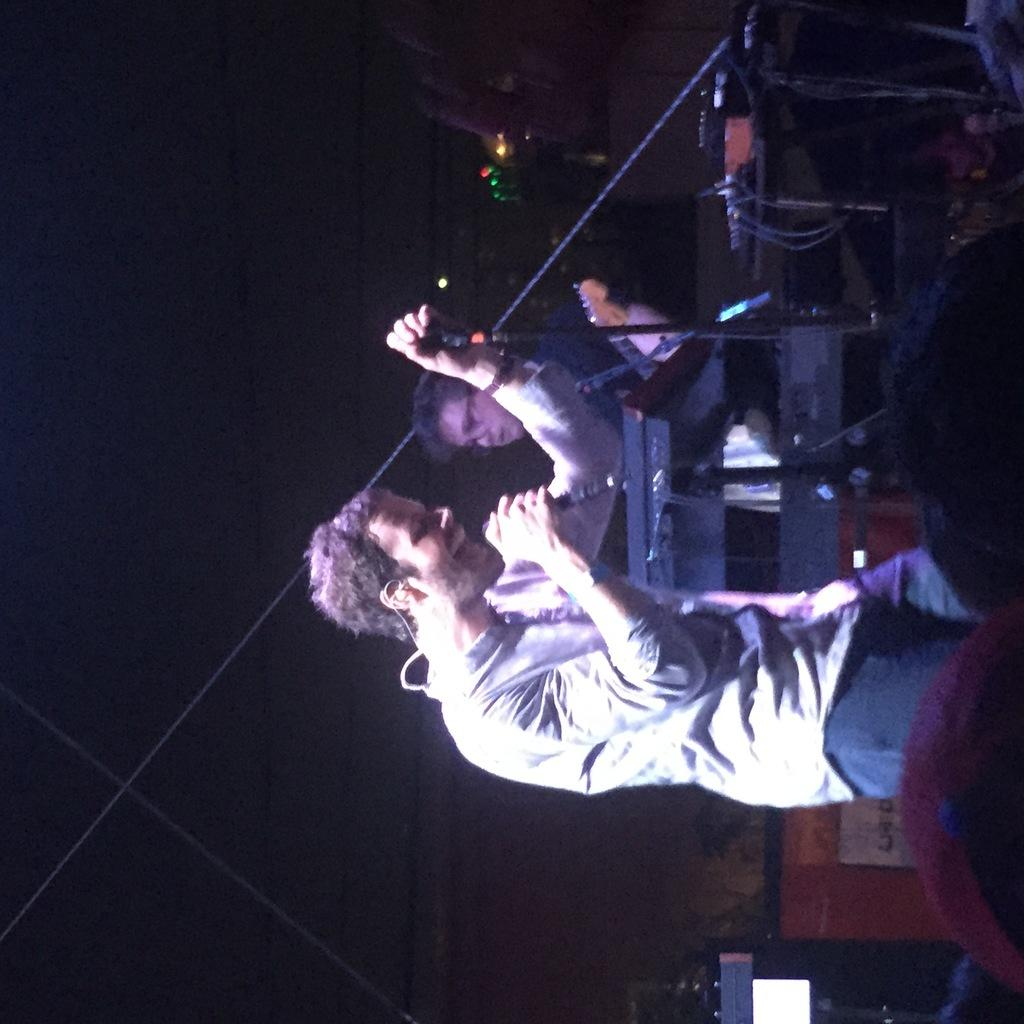What is happening on the stage in the image? There are people standing on the stage. What are the people on the stage doing? One person is holding a microphone, and another person is playing a musical instrument. What type of surprise can be seen on the elbow of the person playing the musical instrument? There is no surprise or any indication of an elbow in the image, as it only shows people on the stage with a microphone and a musical instrument. 